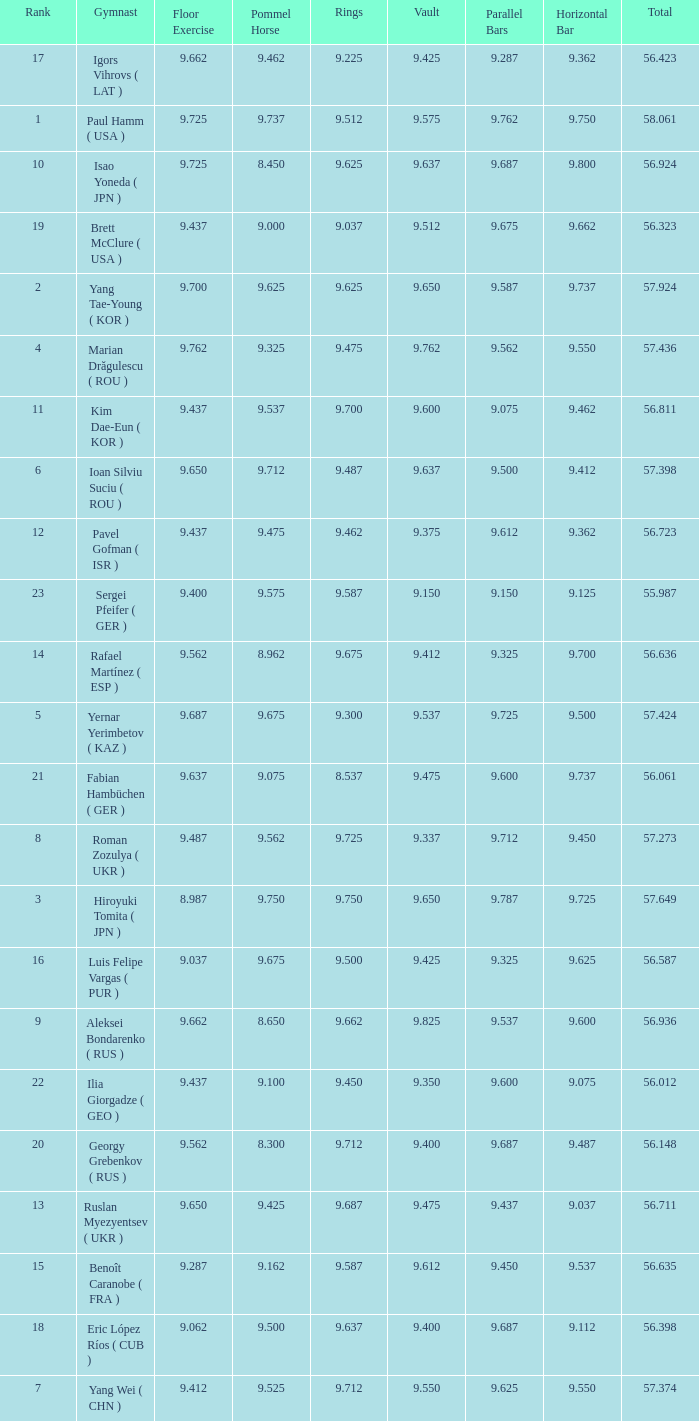What is the vault score for the total of 56.635? 9.612. 